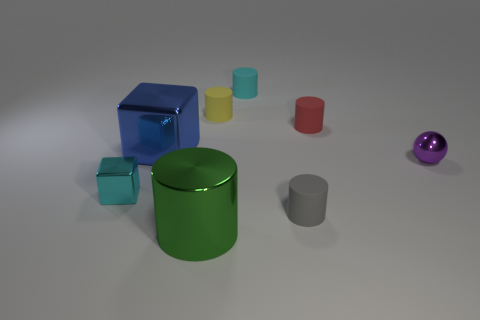Subtract all yellow rubber cylinders. How many cylinders are left? 4 Subtract all green cylinders. How many cylinders are left? 4 Add 2 tiny green matte cubes. How many objects exist? 10 Subtract all cylinders. How many objects are left? 3 Subtract all green cylinders. Subtract all cyan blocks. How many cylinders are left? 4 Add 5 big green objects. How many big green objects are left? 6 Add 4 tiny purple things. How many tiny purple things exist? 5 Subtract 1 cyan cylinders. How many objects are left? 7 Subtract all small balls. Subtract all large blue objects. How many objects are left? 6 